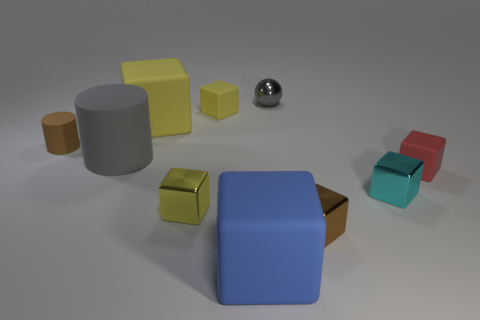Subtract all yellow blocks. How many were subtracted if there are1yellow blocks left? 2 Subtract all red blocks. How many blocks are left? 6 Subtract all yellow balls. How many yellow blocks are left? 3 Subtract all cyan cubes. How many cubes are left? 6 Subtract 1 blocks. How many blocks are left? 6 Subtract all balls. How many objects are left? 9 Subtract 0 green cylinders. How many objects are left? 10 Subtract all brown cylinders. Subtract all brown blocks. How many cylinders are left? 1 Subtract all red things. Subtract all tiny matte cylinders. How many objects are left? 8 Add 3 cyan objects. How many cyan objects are left? 4 